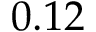<formula> <loc_0><loc_0><loc_500><loc_500>0 . 1 2</formula> 